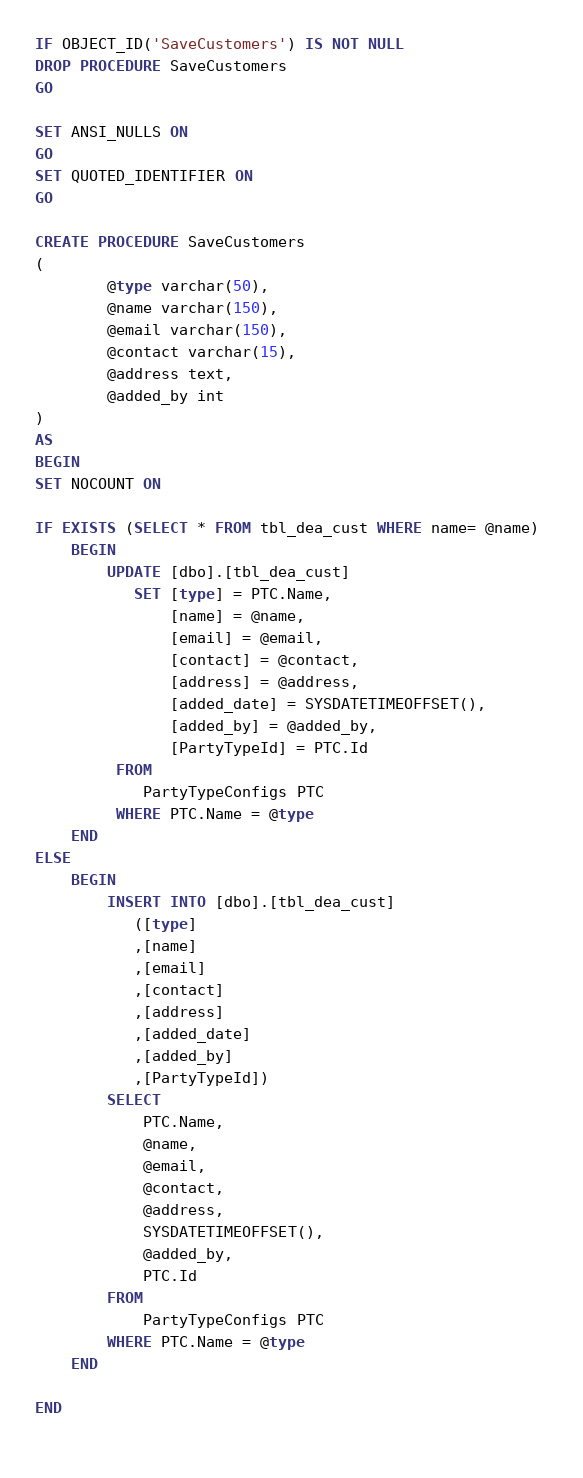<code> <loc_0><loc_0><loc_500><loc_500><_SQL_>
IF OBJECT_ID('SaveCustomers') IS NOT NULL
DROP PROCEDURE SaveCustomers
GO

SET ANSI_NULLS ON
GO
SET QUOTED_IDENTIFIER ON
GO

CREATE PROCEDURE SaveCustomers
(
		@type varchar(50), 
		@name varchar(150), 
		@email varchar(150), 
		@contact varchar(15), 
		@address text,  
		@added_by int
)
AS
BEGIN
SET NOCOUNT ON

IF EXISTS (SELECT * FROM tbl_dea_cust WHERE name= @name) 
	BEGIN
		UPDATE [dbo].[tbl_dea_cust]
		   SET [type] = PTC.Name,
			   [name] = @name,
		       [email] = @email,
		       [contact] = @contact,
		       [address] = @address,
		       [added_date] = SYSDATETIMEOFFSET(),
		       [added_by] = @added_by,
		       [PartyTypeId] = PTC.Id
		 FROM
			PartyTypeConfigs PTC
		 WHERE PTC.Name = @type
	END
ELSE
	BEGIN
		INSERT INTO [dbo].[tbl_dea_cust]
           ([type]
           ,[name]
           ,[email]
           ,[contact]
           ,[address]
           ,[added_date]
           ,[added_by]
           ,[PartyTypeId])
		SELECT
			PTC.Name,
			@name,
			@email,
			@contact,
			@address,
			SYSDATETIMEOFFSET(),
			@added_by,
			PTC.Id
		FROM
			PartyTypeConfigs PTC
		WHERE PTC.Name = @type	
	END

END
	
</code> 